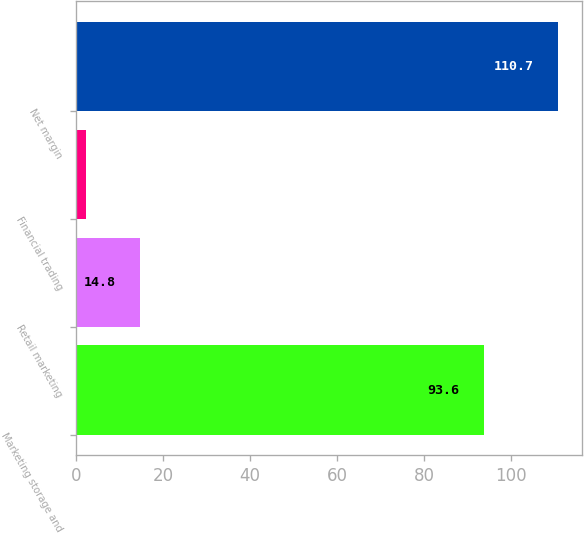Convert chart to OTSL. <chart><loc_0><loc_0><loc_500><loc_500><bar_chart><fcel>Marketing storage and<fcel>Retail marketing<fcel>Financial trading<fcel>Net margin<nl><fcel>93.6<fcel>14.8<fcel>2.3<fcel>110.7<nl></chart> 